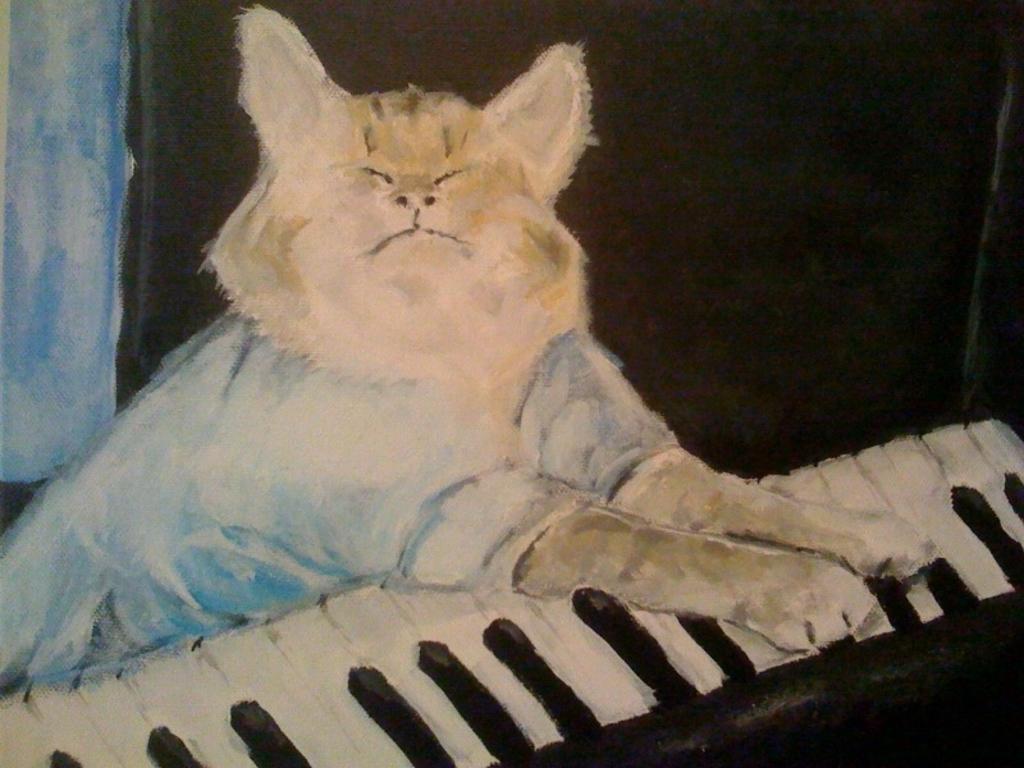How would you summarize this image in a sentence or two? This is a painting of a cat playing a keyboard. In the background it is black. 